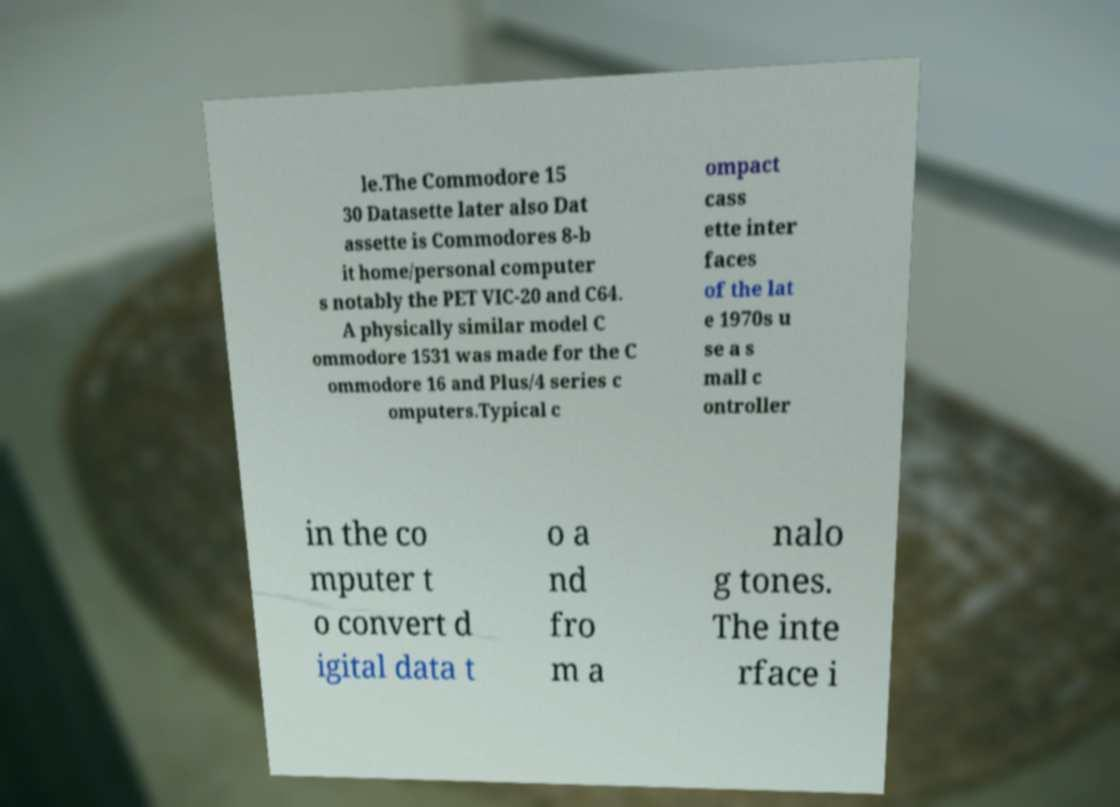Can you read and provide the text displayed in the image?This photo seems to have some interesting text. Can you extract and type it out for me? le.The Commodore 15 30 Datasette later also Dat assette is Commodores 8-b it home/personal computer s notably the PET VIC-20 and C64. A physically similar model C ommodore 1531 was made for the C ommodore 16 and Plus/4 series c omputers.Typical c ompact cass ette inter faces of the lat e 1970s u se a s mall c ontroller in the co mputer t o convert d igital data t o a nd fro m a nalo g tones. The inte rface i 